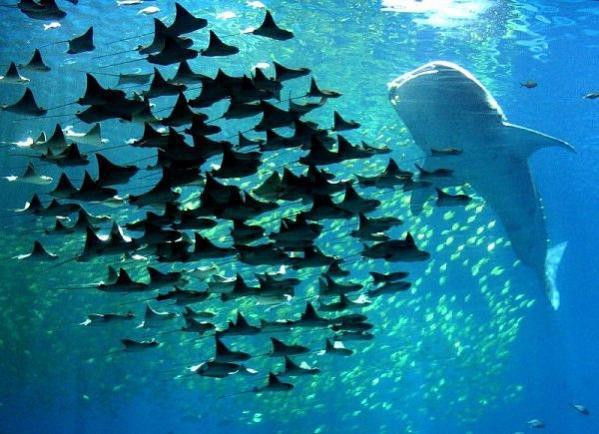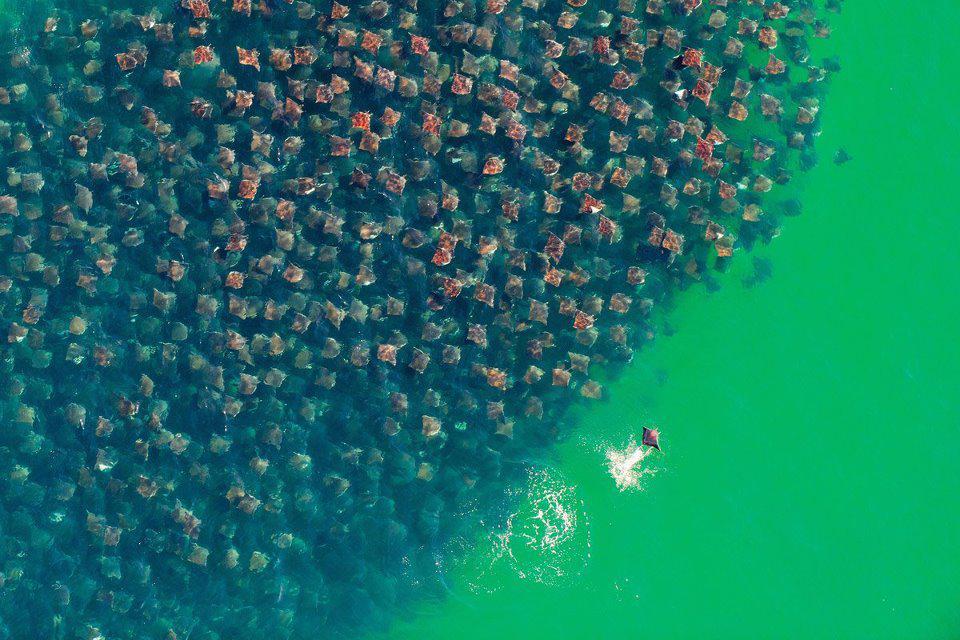The first image is the image on the left, the second image is the image on the right. Examine the images to the left and right. Is the description "There are no more than eight creatures in the image on the right." accurate? Answer yes or no. No. 